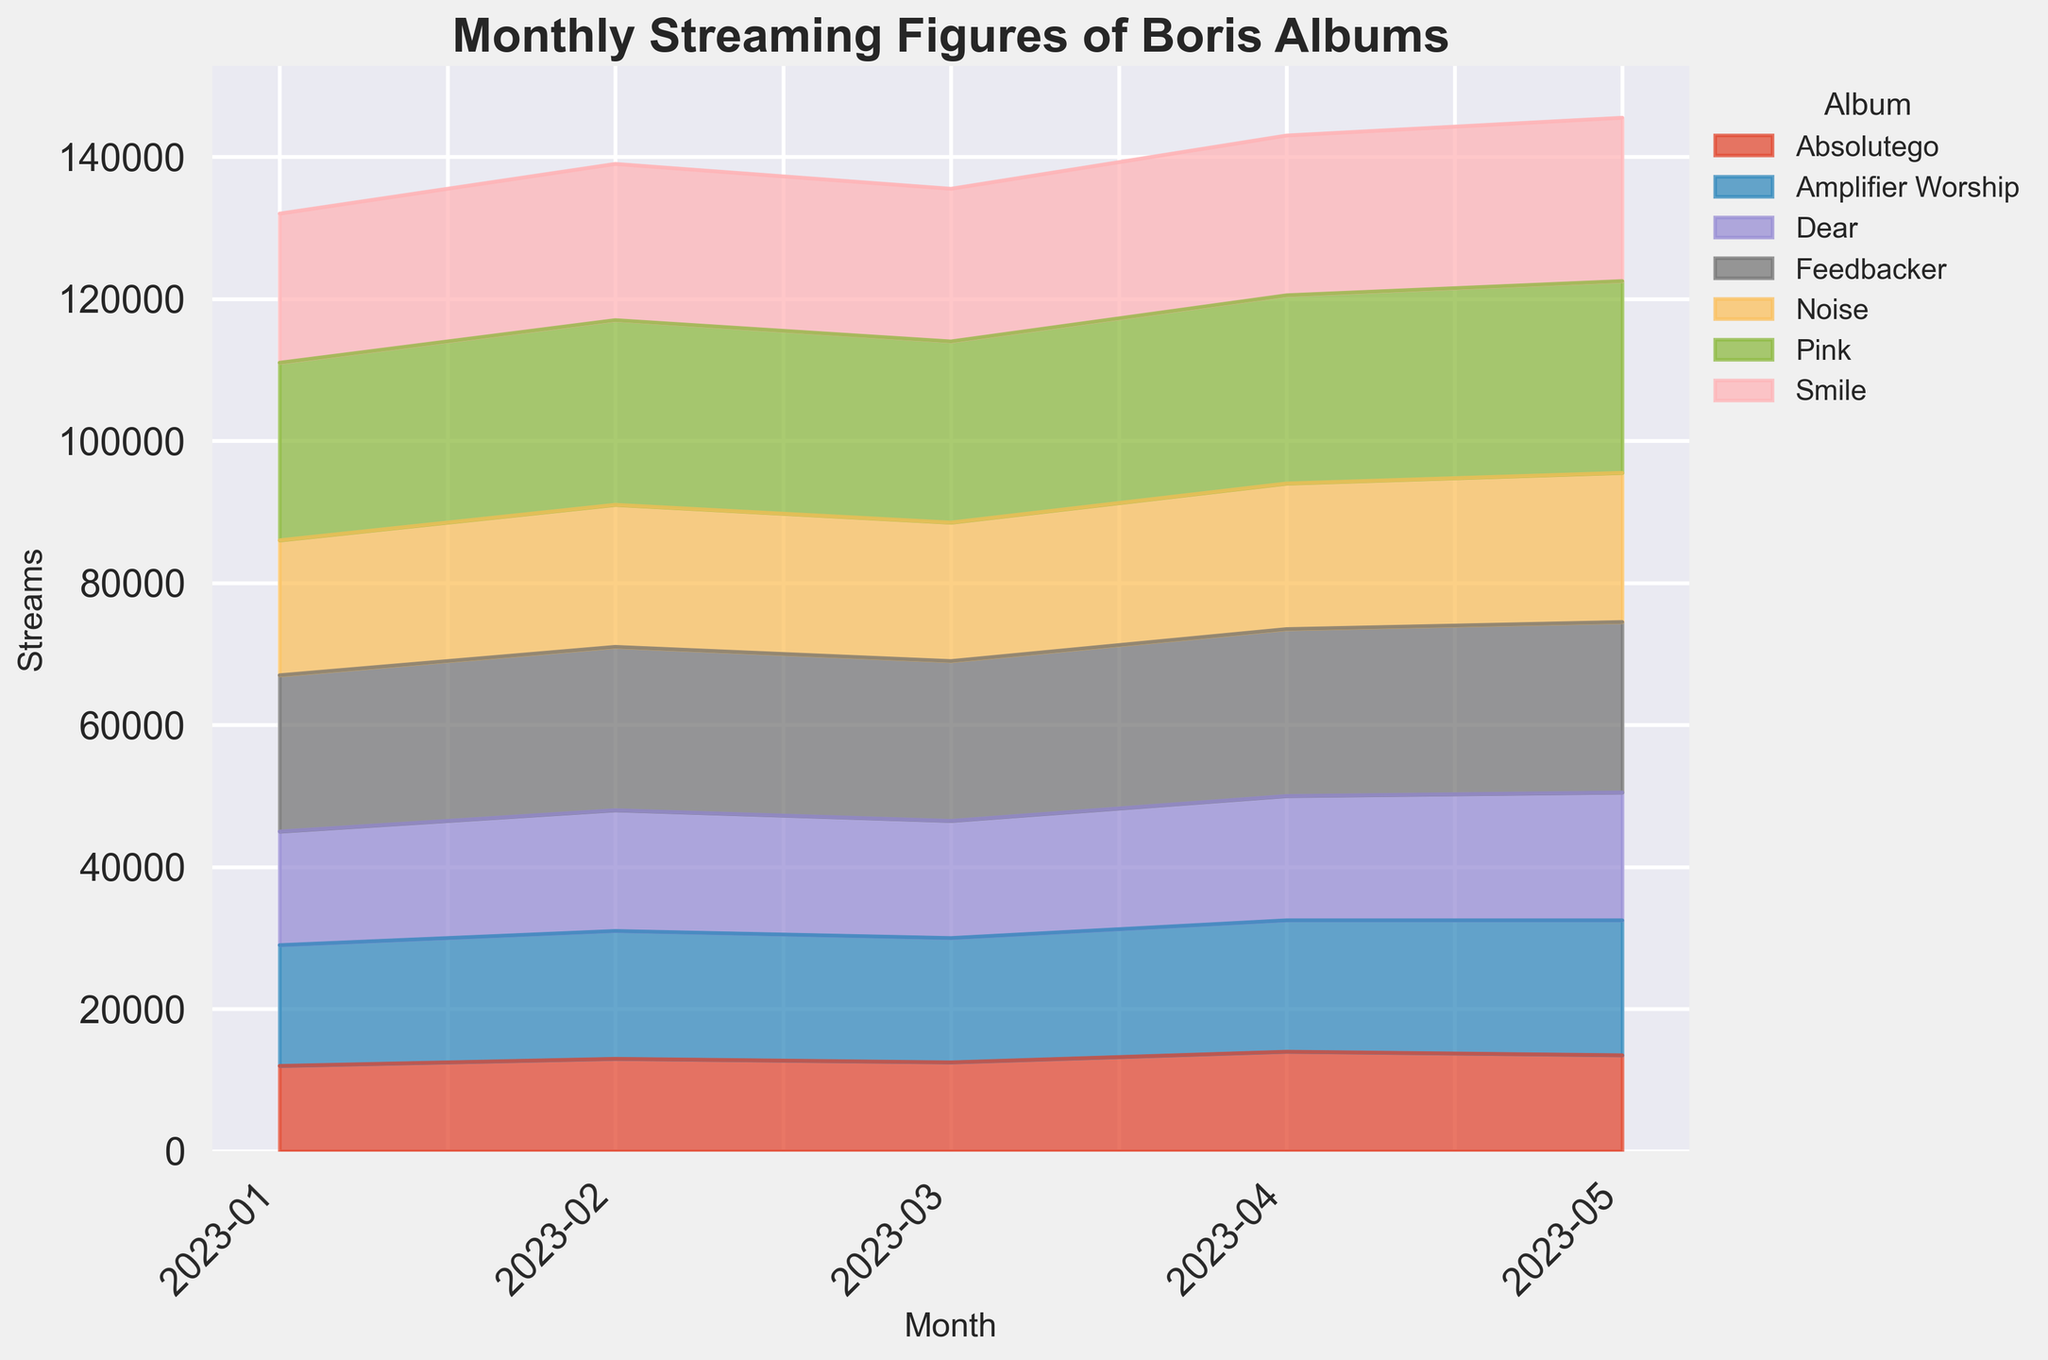What's the total number of streams for "Pink" across all months? First, we look at the heights corresponding to "Pink" in the area chart for each month. They are visually proportional to 25000, 26000, 25500, 26500, 27000 streams for January through May, respectively. Summing these values: 25000 + 26000 + 25500 + 26500 + 27000 = 130000. So, the total streams are 130000.
Answer: 130000 Which album had the highest number of streams in May 2023? By examining the peaks in the figure for May 2023, we notice that one segment at the top is taller than the others. "Pink" had the highest value around 27000 streams in May.
Answer: Pink Did "Amplifier Worship" have more streams in March or April 2023? We compare the segments for "Amplifier Worship" (in orange) between March and April. In March, it had around 17500 streams, whereas in April, it increased to approximately 18500 streams. Therefore, April had more streams.
Answer: April How many more streams did "Feedbacker" have in April compared to February 2023? Identifying the heights for "Feedbacker" (in green) for both months, April shows around 23500 streams, and February around 23000 streams. The difference is 23500 - 23000 = 500 streams.
Answer: 500 Rank the albums by their total streams in January 2023. Analyzing the bottoms of the area chart for January, from lowest to highest: "Absolutego" (12000), "Dear" (16000), "Noise" (19000), "Smile" (21000), "Amplifier Worship" (17000), "Feedbacker" (22000), and "Pink" (25000). Thus, the rankings are: 1. Pink, 2. Feedbacker, 3. Smile, 4. Noise, 5. Dear, 6. Amplifier Worship, 7. Absolutego.
Answer: 1. Pink, 2. Feedbacker, 3. Smile, 4. Noise, 5. Dear, 6. Amplifier Worship, 7. Absolutego What's the average monthly streams for "Noise" in the given period? Assess the figures for "Noise" for each month: January (19000), February (20000), March (19500), April (20500), May (21000). Sum these values: 19000 + 20000 + 19500 + 20500 + 21000 = 100000. Divide by 5 months: 100000 / 5 = 20000. Thus, the average is 20000 streams.
Answer: 20000 Which two albums' streaming figures were closest in April 2023? Examining the heights of April segments, we observe "Absolutego" (14000) and "Dear" (17500) are visually closer than the others. Their difference is around 17500 - 14000 = 3500 streams. Other comparisons show larger differences.
Answer: Absolutego and Dear What is the trend observed in the streaming figures for "Smile" from January to May 2023? Observing the green sections for each month from January to May, we see a gradual increase: January (21000), February (22000), March (21500), April (22500), May (23000). The overall trend is an upward movement.
Answer: Increasing 